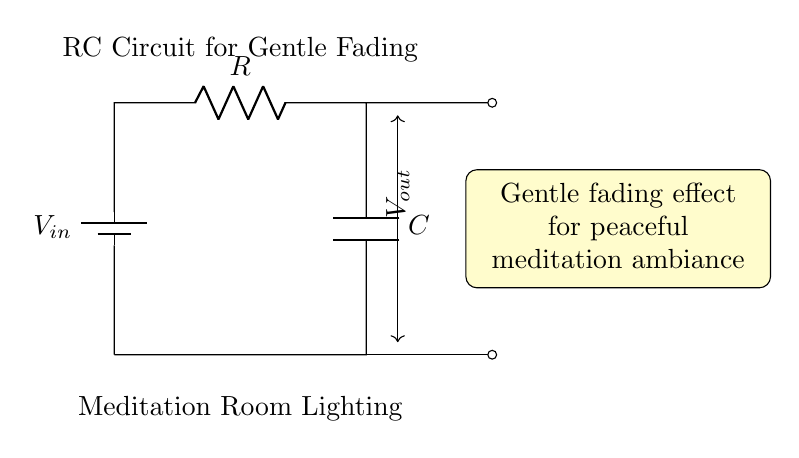What is the input voltage in this circuit? The input voltage is labeled as V_{in}, which represents the voltage supplied to the circuit.
Answer: V_{in} What components are present in this circuit? The circuit contains a battery (voltage source), a resistor, and a capacitor, as indicated by the symbols in the diagram.
Answer: Battery, resistor, capacitor What type of effect does this circuit provide for the lighting? The circuit is designed to create a gentle fading effect, as stated in the description included in the diagram.
Answer: Gentle fading effect What is the role of the capacitor in this circuit? The capacitor stores and releases energy, smoothing out the voltage changes, which contributes to the gentle fading effect.
Answer: Energy storage How does the resistance value affect the fading time? The resistance value directly influences the time constant (τ = R * C), where a higher resistance results in a slower charge/discharge rate, ultimately leading to a longer fading effect.
Answer: Longer fading time What happens to the output voltage when the capacitor is fully charged? When the capacitor is fully charged, the output voltage approaches the input voltage, resulting in maximum light intensity.
Answer: Approaches V_{in} 